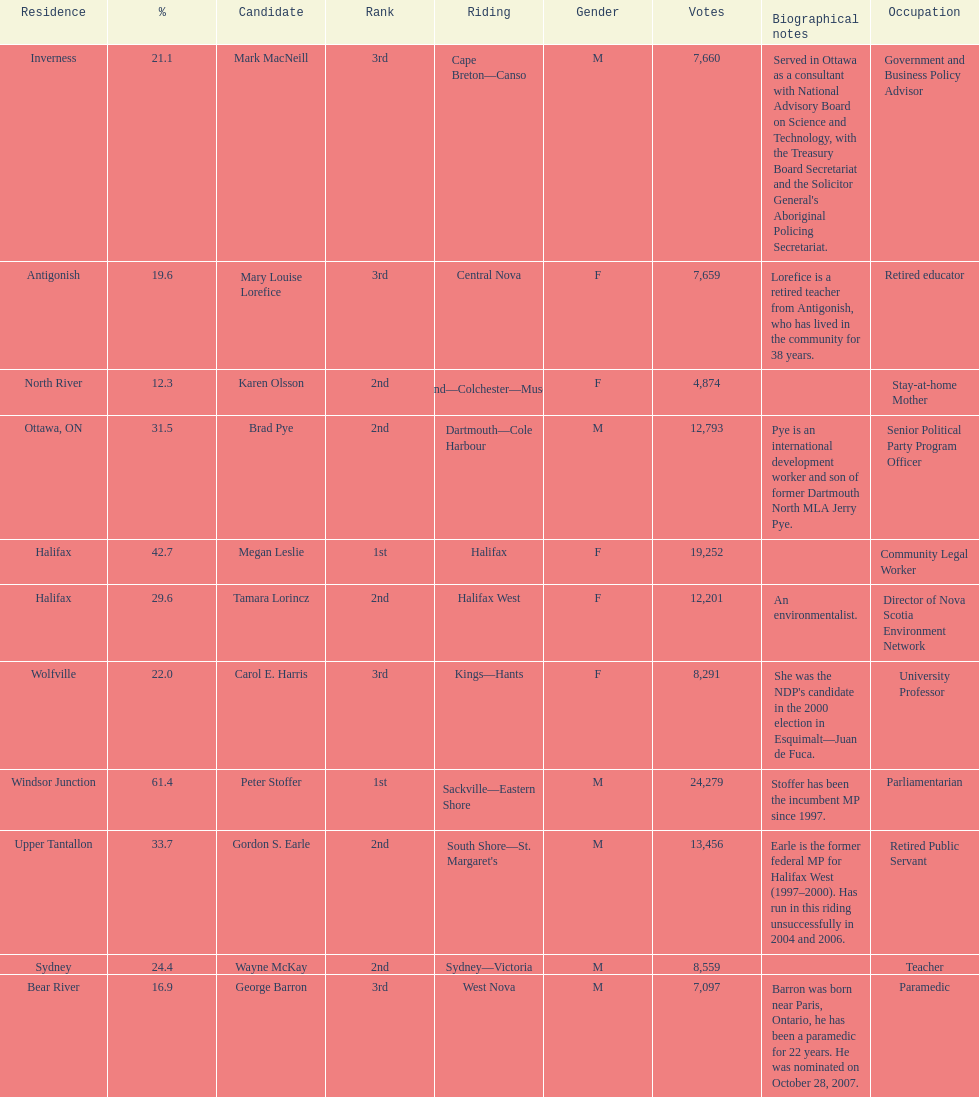What is the first riding? Cape Breton-Canso. Write the full table. {'header': ['Residence', '%', 'Candidate', 'Rank', 'Riding', 'Gender', 'Votes', 'Biographical notes', 'Occupation'], 'rows': [['Inverness', '21.1', 'Mark MacNeill', '3rd', 'Cape Breton—Canso', 'M', '7,660', "Served in Ottawa as a consultant with National Advisory Board on Science and Technology, with the Treasury Board Secretariat and the Solicitor General's Aboriginal Policing Secretariat.", 'Government and Business Policy Advisor'], ['Antigonish', '19.6', 'Mary Louise Lorefice', '3rd', 'Central Nova', 'F', '7,659', 'Lorefice is a retired teacher from Antigonish, who has lived in the community for 38 years.', 'Retired educator'], ['North River', '12.3', 'Karen Olsson', '2nd', 'Cumberland—Colchester—Musquodoboit Valley', 'F', '4,874', '', 'Stay-at-home Mother'], ['Ottawa, ON', '31.5', 'Brad Pye', '2nd', 'Dartmouth—Cole Harbour', 'M', '12,793', 'Pye is an international development worker and son of former Dartmouth North MLA Jerry Pye.', 'Senior Political Party Program Officer'], ['Halifax', '42.7', 'Megan Leslie', '1st', 'Halifax', 'F', '19,252', '', 'Community Legal Worker'], ['Halifax', '29.6', 'Tamara Lorincz', '2nd', 'Halifax West', 'F', '12,201', 'An environmentalist.', 'Director of Nova Scotia Environment Network'], ['Wolfville', '22.0', 'Carol E. Harris', '3rd', 'Kings—Hants', 'F', '8,291', "She was the NDP's candidate in the 2000 election in Esquimalt—Juan de Fuca.", 'University Professor'], ['Windsor Junction', '61.4', 'Peter Stoffer', '1st', 'Sackville—Eastern Shore', 'M', '24,279', 'Stoffer has been the incumbent MP since 1997.', 'Parliamentarian'], ['Upper Tantallon', '33.7', 'Gordon S. Earle', '2nd', "South Shore—St. Margaret's", 'M', '13,456', 'Earle is the former federal MP for Halifax West (1997–2000). Has run in this riding unsuccessfully in 2004 and 2006.', 'Retired Public Servant'], ['Sydney', '24.4', 'Wayne McKay', '2nd', 'Sydney—Victoria', 'M', '8,559', '', 'Teacher'], ['Bear River', '16.9', 'George Barron', '3rd', 'West Nova', 'M', '7,097', 'Barron was born near Paris, Ontario, he has been a paramedic for 22 years. He was nominated on October 28, 2007.', 'Paramedic']]} 